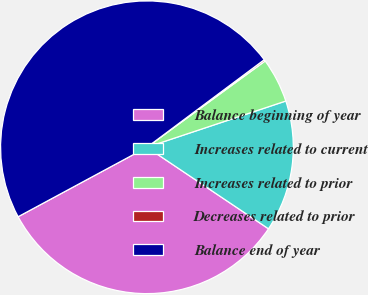Convert chart. <chart><loc_0><loc_0><loc_500><loc_500><pie_chart><fcel>Balance beginning of year<fcel>Increases related to current<fcel>Increases related to prior<fcel>Decreases related to prior<fcel>Balance end of year<nl><fcel>32.73%<fcel>14.52%<fcel>4.92%<fcel>0.17%<fcel>47.67%<nl></chart> 